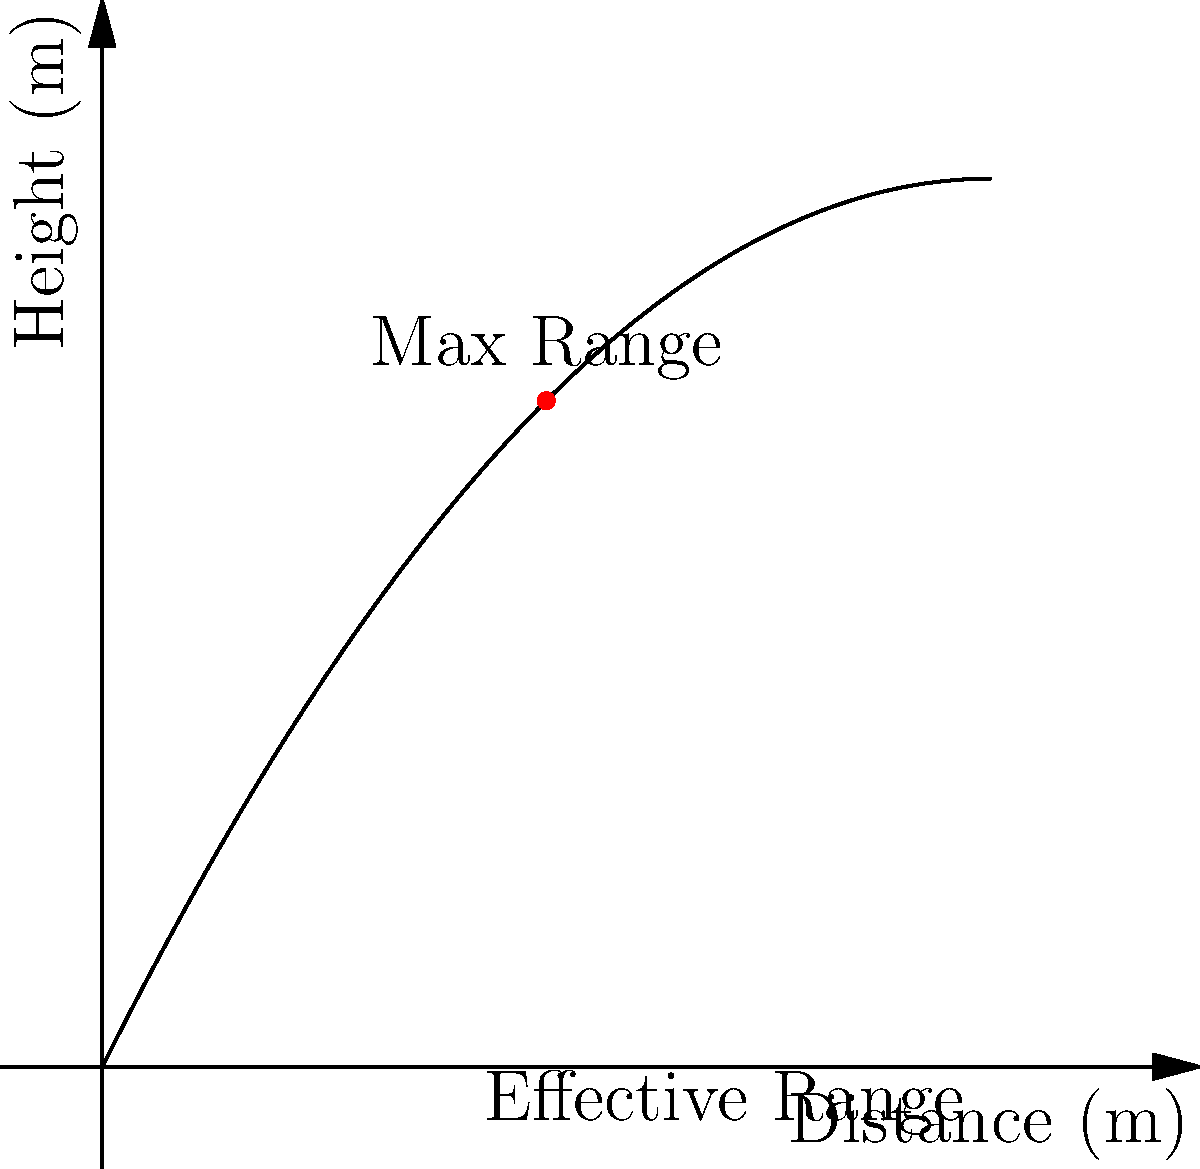Officer Chuckles, you're testing a new taser model. The arc of the taser wire can be described by the polynomial function $f(x) = -0.1x^2 + 2x$, where $x$ is the horizontal distance and $f(x)$ is the height, both in meters. What's the maximum effective range of this taser, rounded to the nearest meter? (Hint: The wire becomes ineffective when it touches the ground.) Let's approach this step-by-step:

1) The taser wire becomes ineffective when it touches the ground, which means when $f(x) = 0$.

2) We need to solve the equation: $-0.1x^2 + 2x = 0$

3) Factor out x: $x(-0.1x + 2) = 0$

4) Solve for x:
   $x = 0$ or $-0.1x + 2 = 0$
   $x = 0$ or $x = 20$

5) The solution $x = 0$ represents the starting point. The solution $x = 20$ represents where the wire would touch the ground if it could extend that far.

6) However, the maximum of the function occurs at the midpoint between these roots, which is at $x = 10$ meters.

7) The effective range will be slightly less than this maximum point.

8) We can find the exact point by solving $f(x) = 0$, but rounding to the nearest meter, the effective range is 10 meters.
Answer: 10 meters 